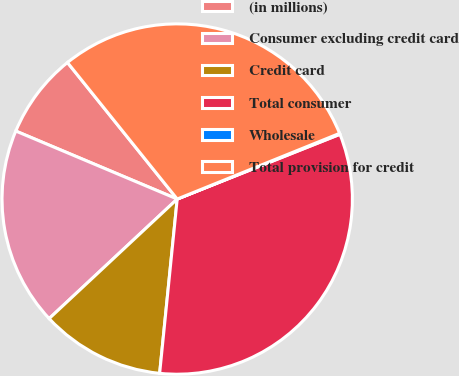Convert chart. <chart><loc_0><loc_0><loc_500><loc_500><pie_chart><fcel>(in millions)<fcel>Consumer excluding credit card<fcel>Credit card<fcel>Total consumer<fcel>Wholesale<fcel>Total provision for credit<nl><fcel>7.88%<fcel>18.3%<fcel>11.45%<fcel>32.63%<fcel>0.09%<fcel>29.66%<nl></chart> 